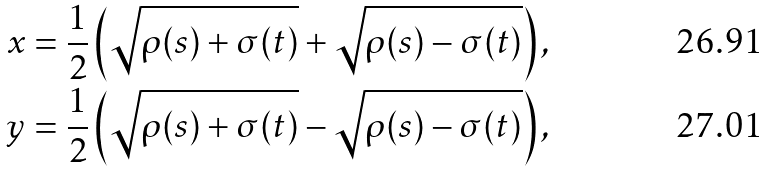<formula> <loc_0><loc_0><loc_500><loc_500>x & = \frac { 1 } { 2 } \left ( \sqrt { \rho ( s ) + \sigma ( t ) } + \sqrt { \rho ( s ) - \sigma ( t ) } \right ) , \\ y & = \frac { 1 } { 2 } \left ( \sqrt { \rho ( s ) + \sigma ( t ) } - \sqrt { \rho ( s ) - \sigma ( t ) } \right ) ,</formula> 